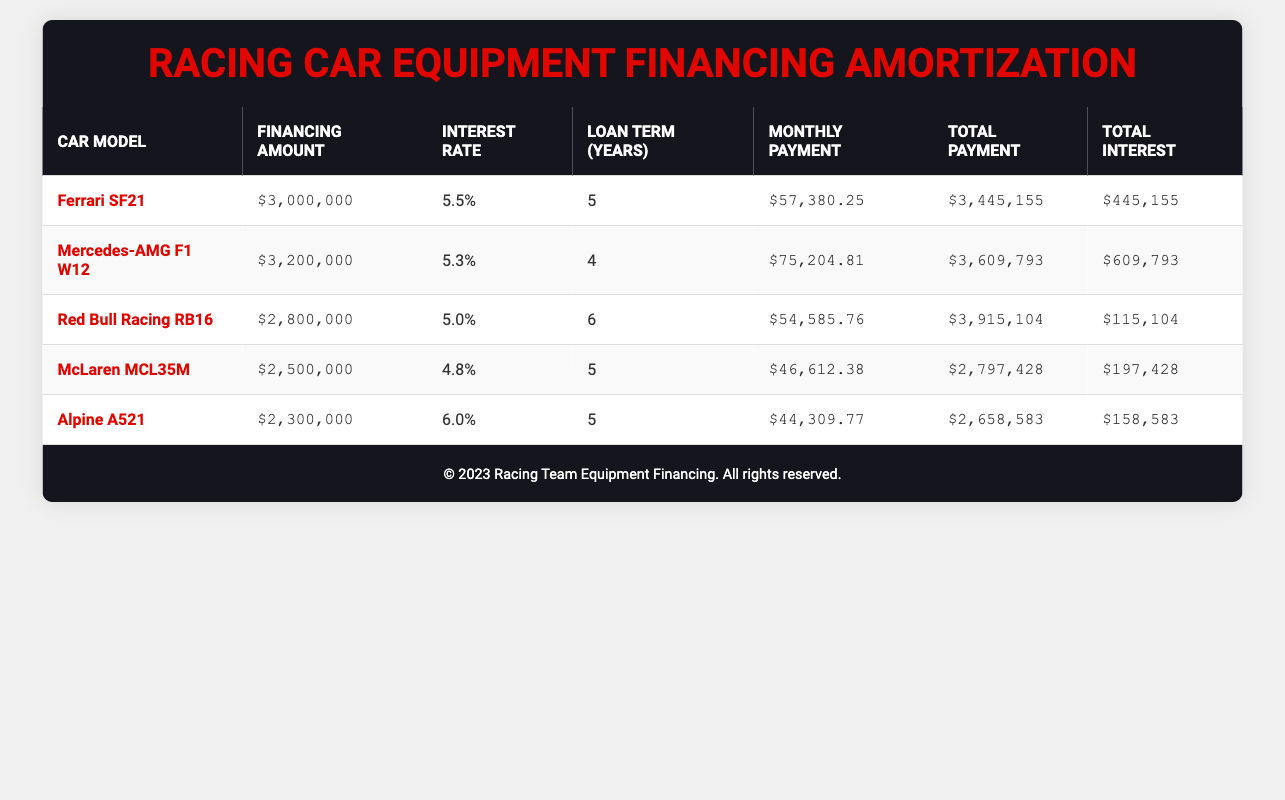What is the total payment for the Ferrari SF21? According to the table, the total payment listed for the Ferrari SF21 is $3,445,155.
Answer: $3,445,155 What is the monthly payment for the Mercedes-AMG F1 W12? The table states the monthly payment for the Mercedes-AMG F1 W12 is $75,204.81.
Answer: $75,204.81 Which car has the highest total interest payment? By checking the total interest payments for all cars, the Mercedes-AMG F1 W12 has the highest total interest at $609,793.
Answer: Yes What is the financing amount for the McLaren MCL35M? The table indicates that the financing amount for the McLaren MCL35M is $2,500,000.
Answer: $2,500,000 What is the average interest rate for the cars listed? The interest rates for the cars are 5.5, 5.3, 5.0, 4.8, and 6.0. The total is 5.5 + 5.3 + 5.0 + 4.8 + 6.0 = 26.6. To find the average, divide by the number of cars (5), giving 26.6 / 5 = 5.32.
Answer: 5.32 Is the total payment for the Red Bull Racing RB16 lower than $4,000,000? The table shows the total payment for the Red Bull Racing RB16 is $3,915,104, which is indeed lower than $4,000,000.
Answer: Yes What is the difference in monthly payments between the Ferrari SF21 and the Alpine A521? The monthly payment for the Ferrari SF21 is $57,380.25 and for the Alpine A521 it is $44,309.77. The difference is calculated as $57,380.25 - $44,309.77 = $13,070.48.
Answer: $13,070.48 Which car model has the lowest financing amount? From the table, the car with the lowest financing amount is the Alpine A521, which has a financing amount of $2,300,000.
Answer: Alpine A521 How much more total payment does the Mercedes-AMG F1 W12 have compared to the McLaren MCL35M? The total payment for the Mercedes-AMG F1 W12 is $3,609,793, and for the McLaren MCL35M, it is $2,797,428. The difference is $3,609,793 - $2,797,428 = $812,365.
Answer: $812,365 